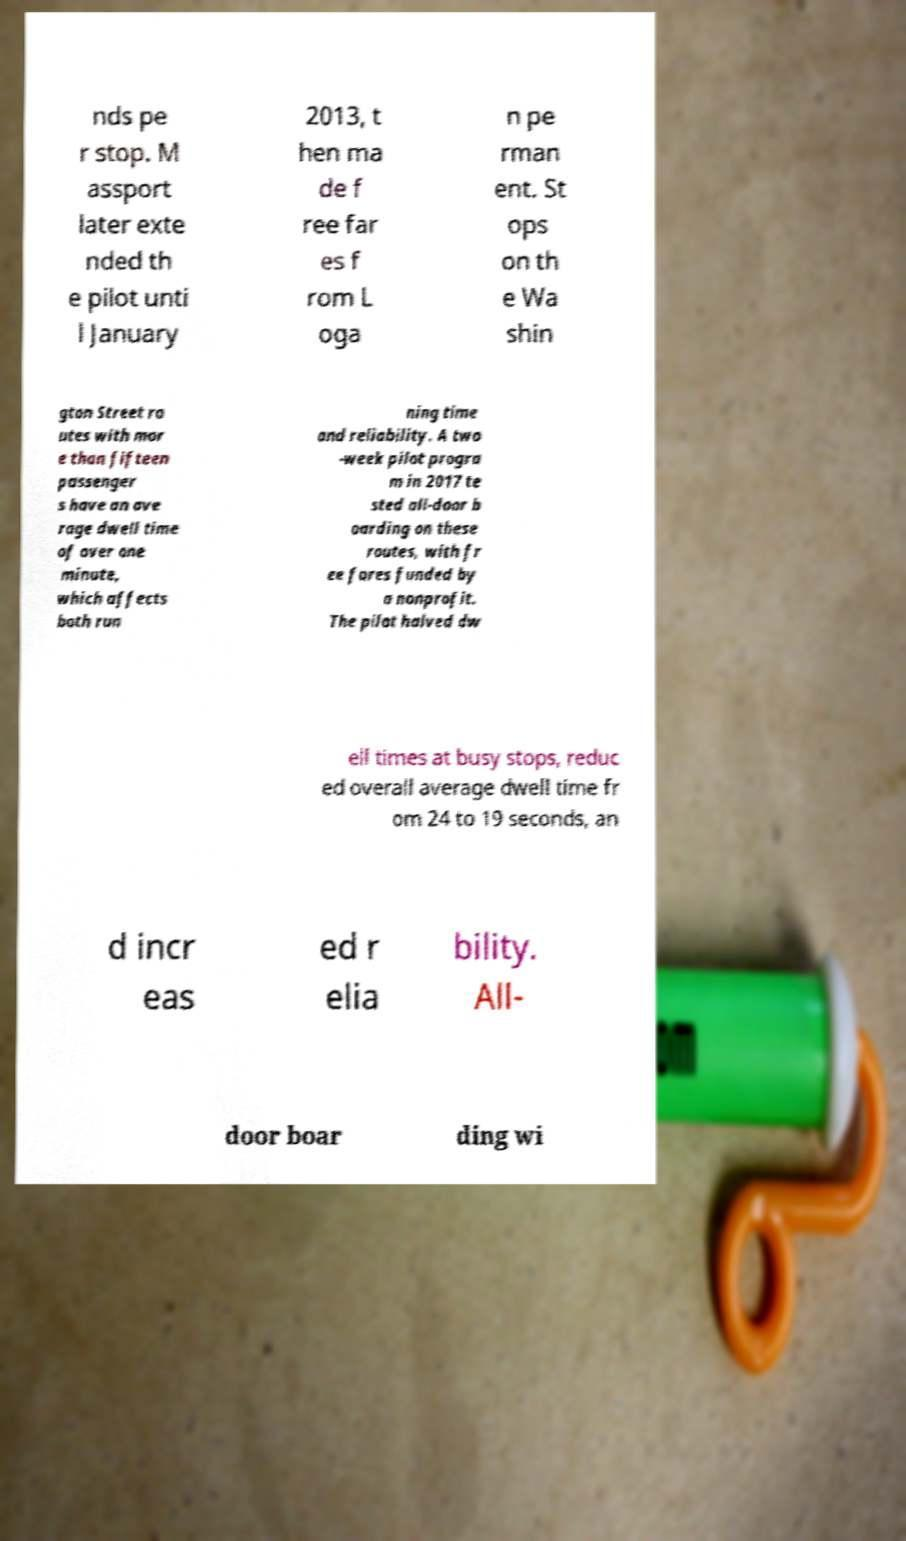Can you accurately transcribe the text from the provided image for me? nds pe r stop. M assport later exte nded th e pilot unti l January 2013, t hen ma de f ree far es f rom L oga n pe rman ent. St ops on th e Wa shin gton Street ro utes with mor e than fifteen passenger s have an ave rage dwell time of over one minute, which affects both run ning time and reliability. A two -week pilot progra m in 2017 te sted all-door b oarding on these routes, with fr ee fares funded by a nonprofit. The pilot halved dw ell times at busy stops, reduc ed overall average dwell time fr om 24 to 19 seconds, an d incr eas ed r elia bility. All- door boar ding wi 